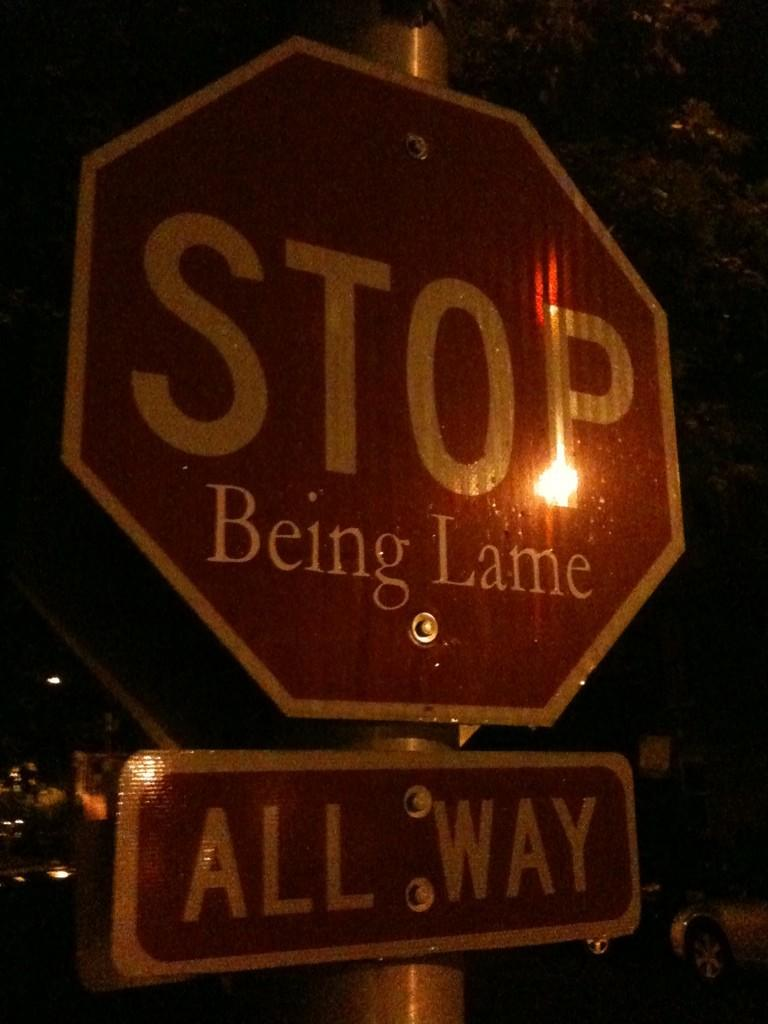<image>
Give a short and clear explanation of the subsequent image. Someone made a good joke out of a stop sign. 